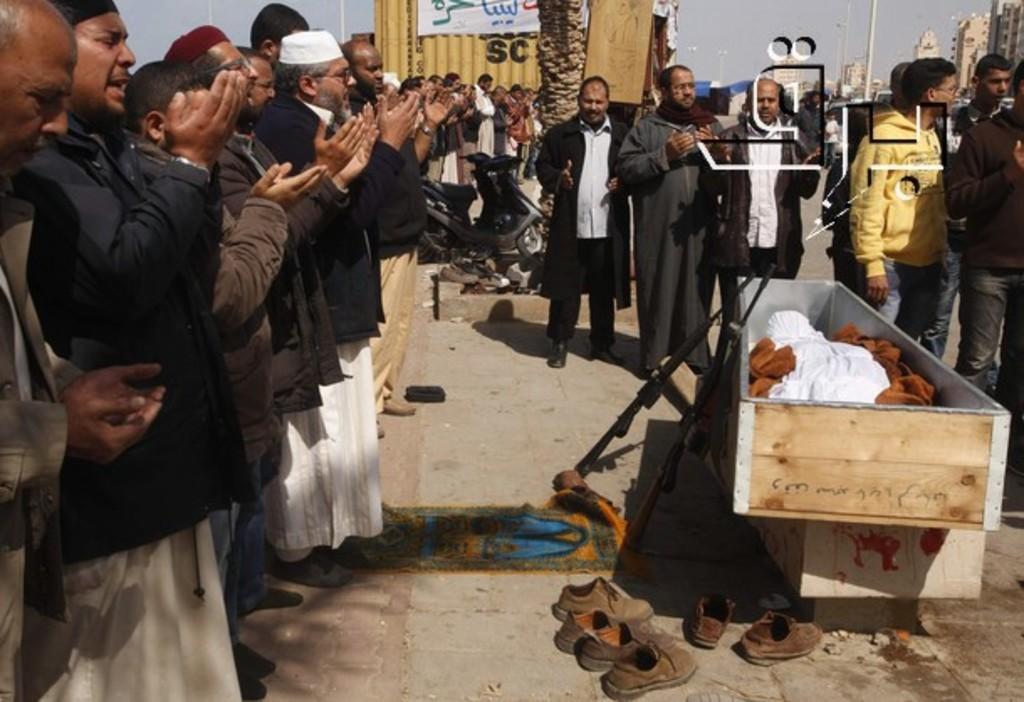In one or two sentences, can you explain what this image depicts? In the image we can see there are many people wearing clothes and shoes, some of them are wearing a cap and spectacles. This is a wooden box, gun, footpath, buildings, pole and a sky. This is a white cloth and this is a vehicle. 